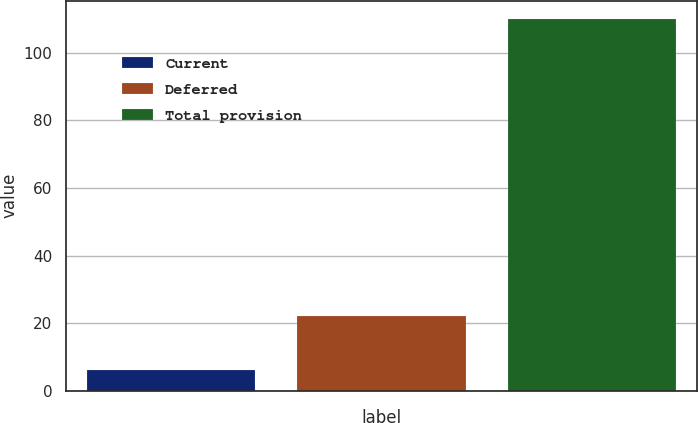<chart> <loc_0><loc_0><loc_500><loc_500><bar_chart><fcel>Current<fcel>Deferred<fcel>Total provision<nl><fcel>6<fcel>22<fcel>110<nl></chart> 